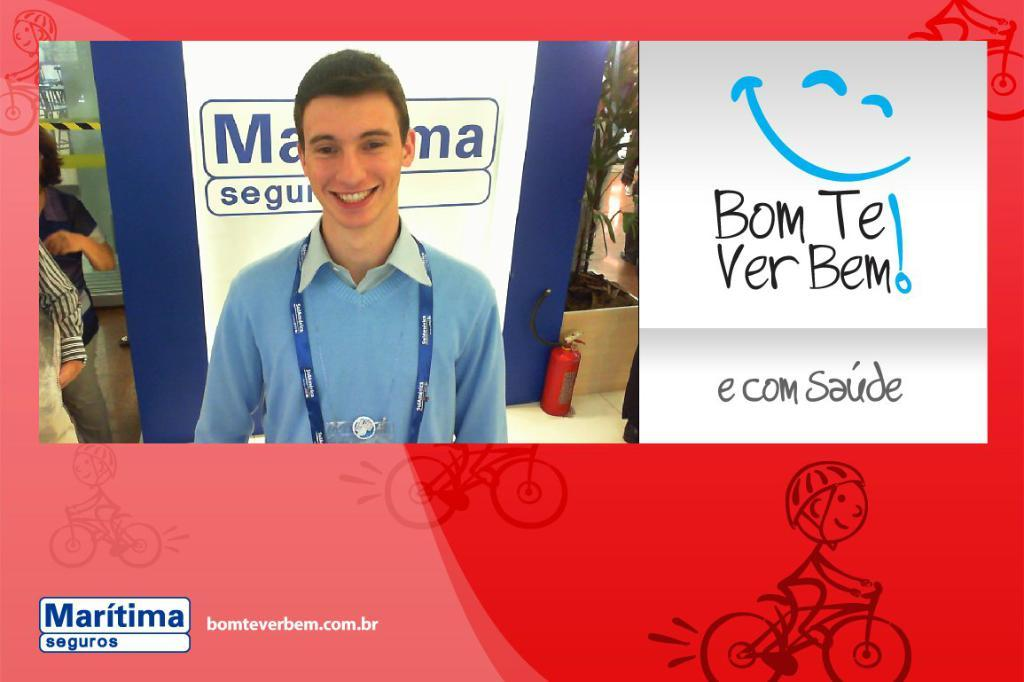Provide a one-sentence caption for the provided image. A smiling guy in a blue shirt next to a Bom Te Verbem! sign. 